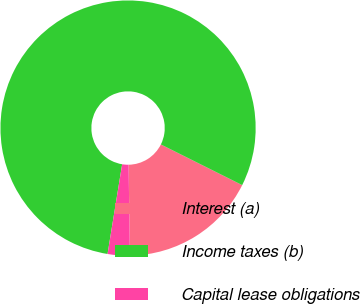<chart> <loc_0><loc_0><loc_500><loc_500><pie_chart><fcel>Interest (a)<fcel>Income taxes (b)<fcel>Capital lease obligations<nl><fcel>17.39%<fcel>79.81%<fcel>2.8%<nl></chart> 